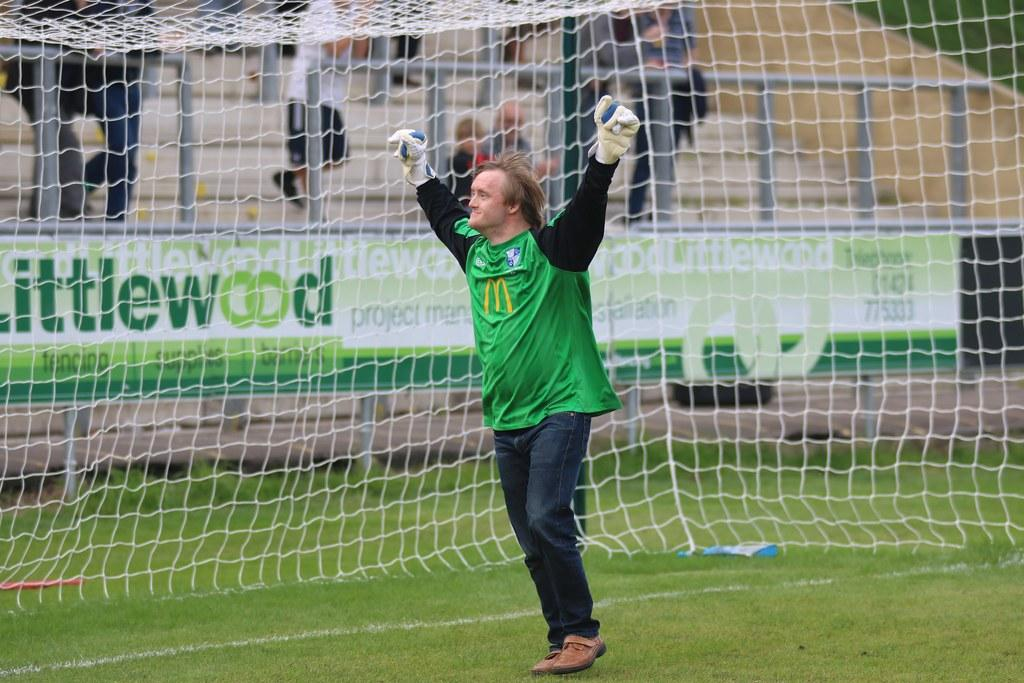Provide a one-sentence caption for the provided image. The goalkeeper celebrates behind a banner that reads Littlewood. 